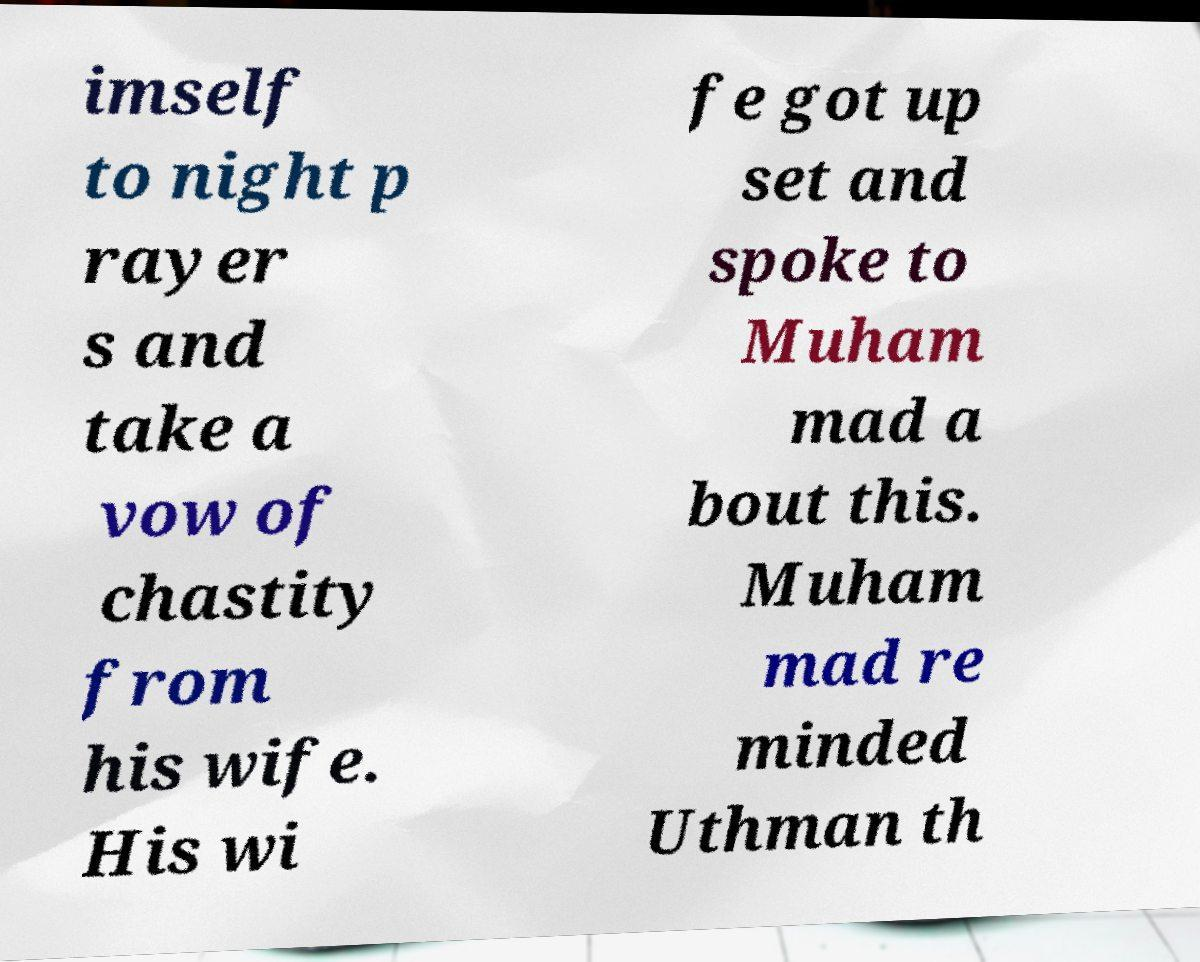Could you assist in decoding the text presented in this image and type it out clearly? imself to night p rayer s and take a vow of chastity from his wife. His wi fe got up set and spoke to Muham mad a bout this. Muham mad re minded Uthman th 